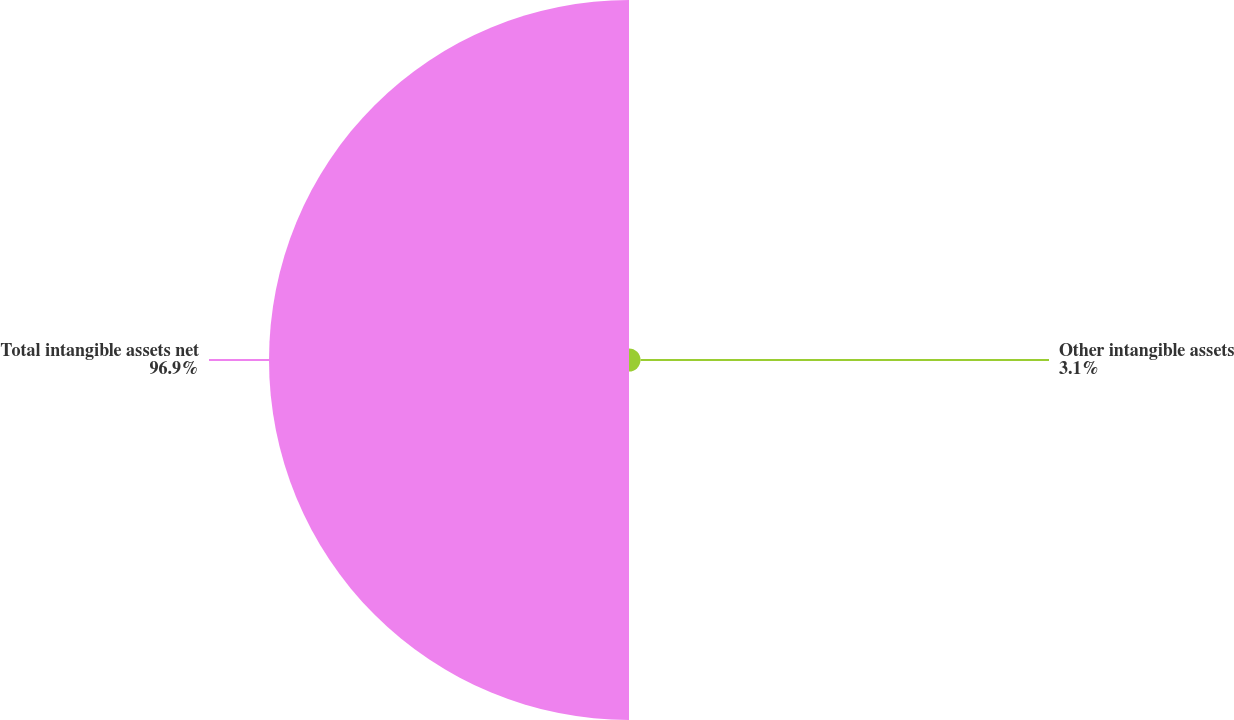<chart> <loc_0><loc_0><loc_500><loc_500><pie_chart><fcel>Other intangible assets<fcel>Total intangible assets net<nl><fcel>3.1%<fcel>96.9%<nl></chart> 